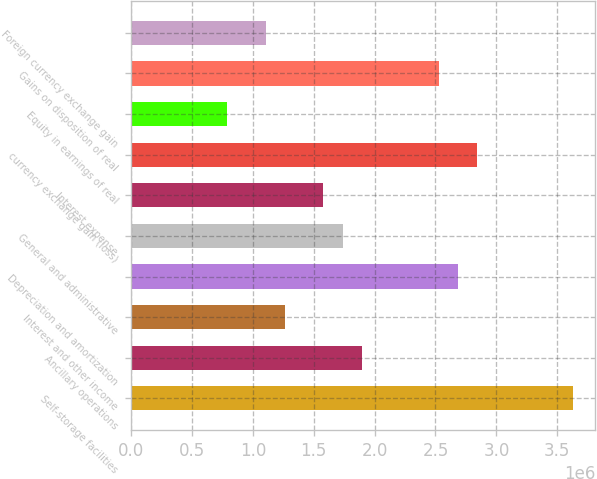Convert chart to OTSL. <chart><loc_0><loc_0><loc_500><loc_500><bar_chart><fcel>Self-storage facilities<fcel>Ancillary operations<fcel>Interest and other income<fcel>Depreciation and amortization<fcel>General and administrative<fcel>Interest expense<fcel>currency exchange gain (loss)<fcel>Equity in earnings of real<fcel>Gains on disposition of real<fcel>Foreign currency exchange gain<nl><fcel>3.63174e+06<fcel>1.89482e+06<fcel>1.26321e+06<fcel>2.68433e+06<fcel>1.73692e+06<fcel>1.57902e+06<fcel>2.84223e+06<fcel>789510<fcel>2.52643e+06<fcel>1.10531e+06<nl></chart> 